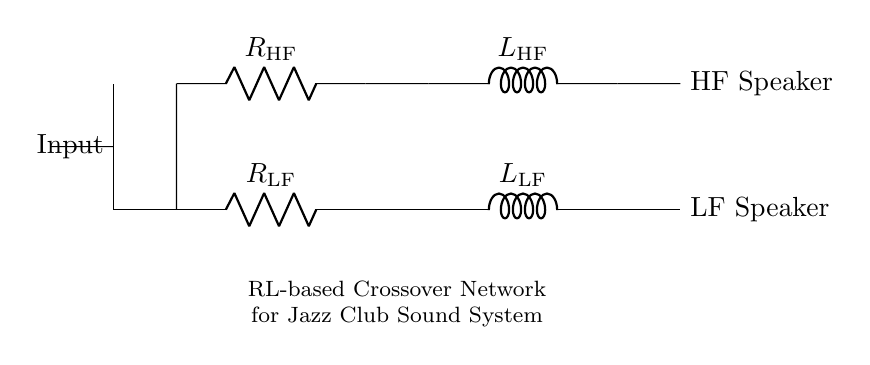What are the components in the circuit? The circuit contains two resistors and two inductors, specifically labeled as R_LF, R_HF, L_LF, and L_HF.
Answer: Resistors and inductors What is the function of R_LF? R_LF is the resistor in the low-frequency section of the crossover network, limiting current and controlling impedance for the LF speaker.
Answer: Current limiting Which speaker receives high frequencies? The circuit includes one HF speaker connected in series with R_HF and L_HF components, filtering signals for high frequencies.
Answer: HF speaker What is the total number of components in the diagram? The diagram contains a total of four primary components: two resistors and two inductors.
Answer: Four How does the RL circuit affect the sound system? The RL circuit allows low-frequency signals to pass to the LF speaker while filtering out high frequencies, optimizing sound quality in the jazz club.
Answer: Filters frequencies What happens to the signal at input? The input signal is divided between the low-frequency and high-frequency sections, allowing different frequency components to reach their respective speakers.
Answer: Signal division How does R_HF affect the circuit? R_HF influences the high-frequency response; it works with L_HF to determine the cutoff frequency and impedance for the HF speaker, ensuring optimal sound quality.
Answer: Controls frequency response 